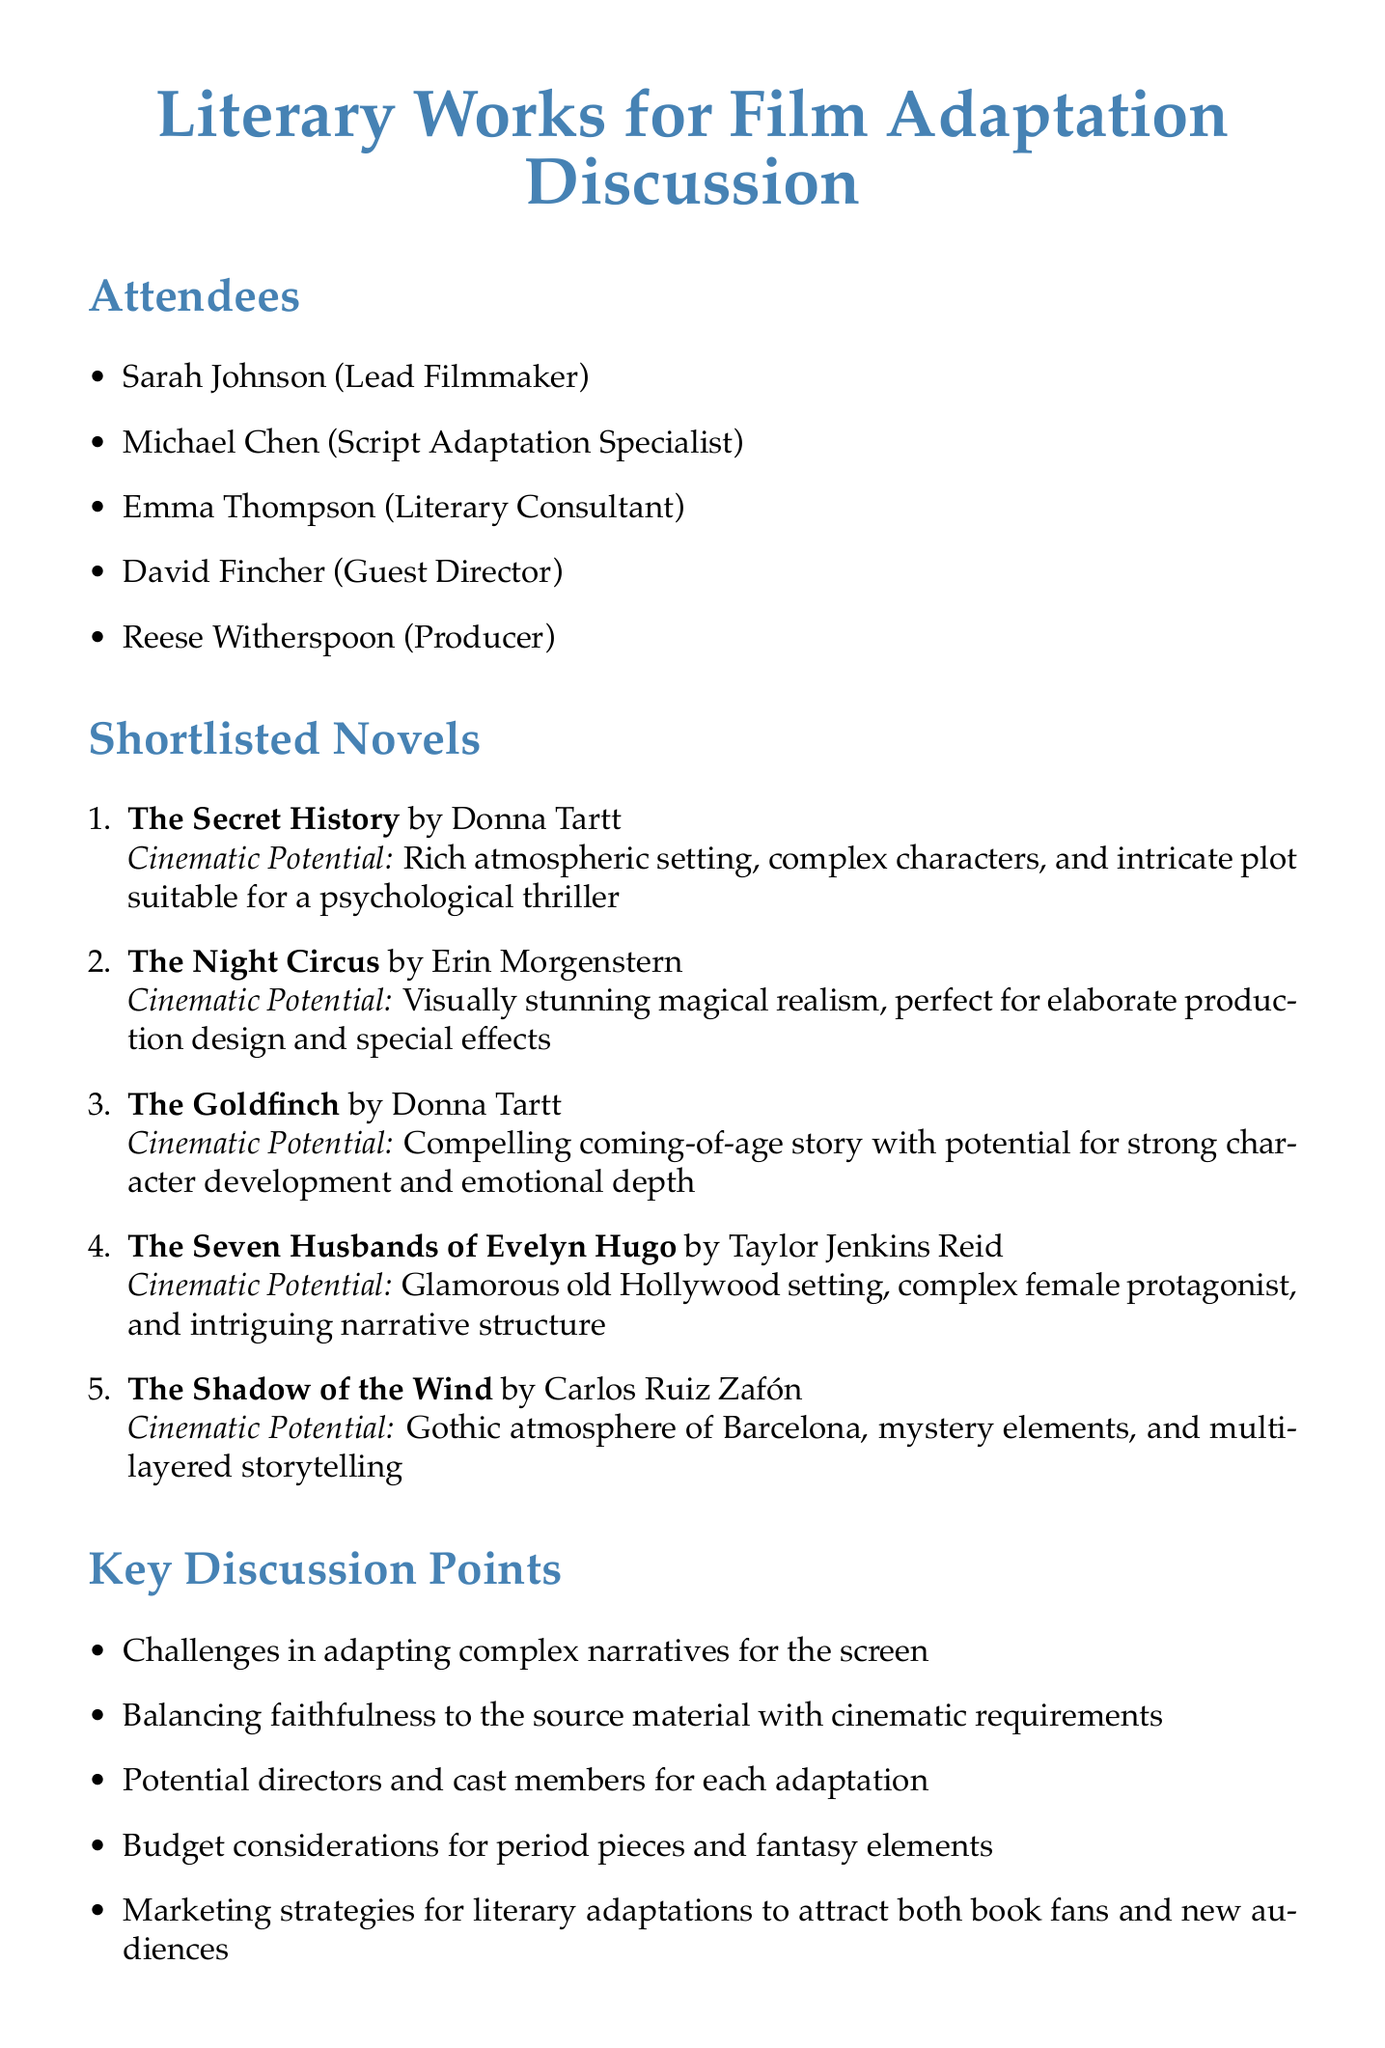What is the title of the meeting? The title of the meeting is stated at the beginning of the document.
Answer: Literary Works for Film Adaptation Discussion Who is the lead filmmaker? The document lists the attendees and identifies Sarah Johnson as the lead filmmaker.
Answer: Sarah Johnson How many novels are on the shortlist? The document enumerates the shortlisted novels in a list which includes five titles.
Answer: 5 Who is the author of "The Goldfinch"? The document specifies the author of each shortlisted novel, including "The Goldfinch."
Answer: Donna Tartt What is one key discussion point mentioned? The document lists several key discussion points, any of which can be cited.
Answer: Challenges in adapting complex narratives for the screen What is the cinematic potential of "The Night Circus"? The document describes the cinematic potential for each shortlisted novel, specifically for "The Night Circus."
Answer: Visually stunning magical realism, perfect for elaborate production design and special effects When is the next meeting scheduled? The document indicates the date of the next meeting towards the end.
Answer: June 15, 2023 What action item involves contacting rights holders? The action items section of the document states specific tasks, including contacting rights holders.
Answer: Contact rights holders for shortlisted novels Who is the producer in the meeting? The document lists the attendees and identifies the producer among them.
Answer: Reese Witherspoon 